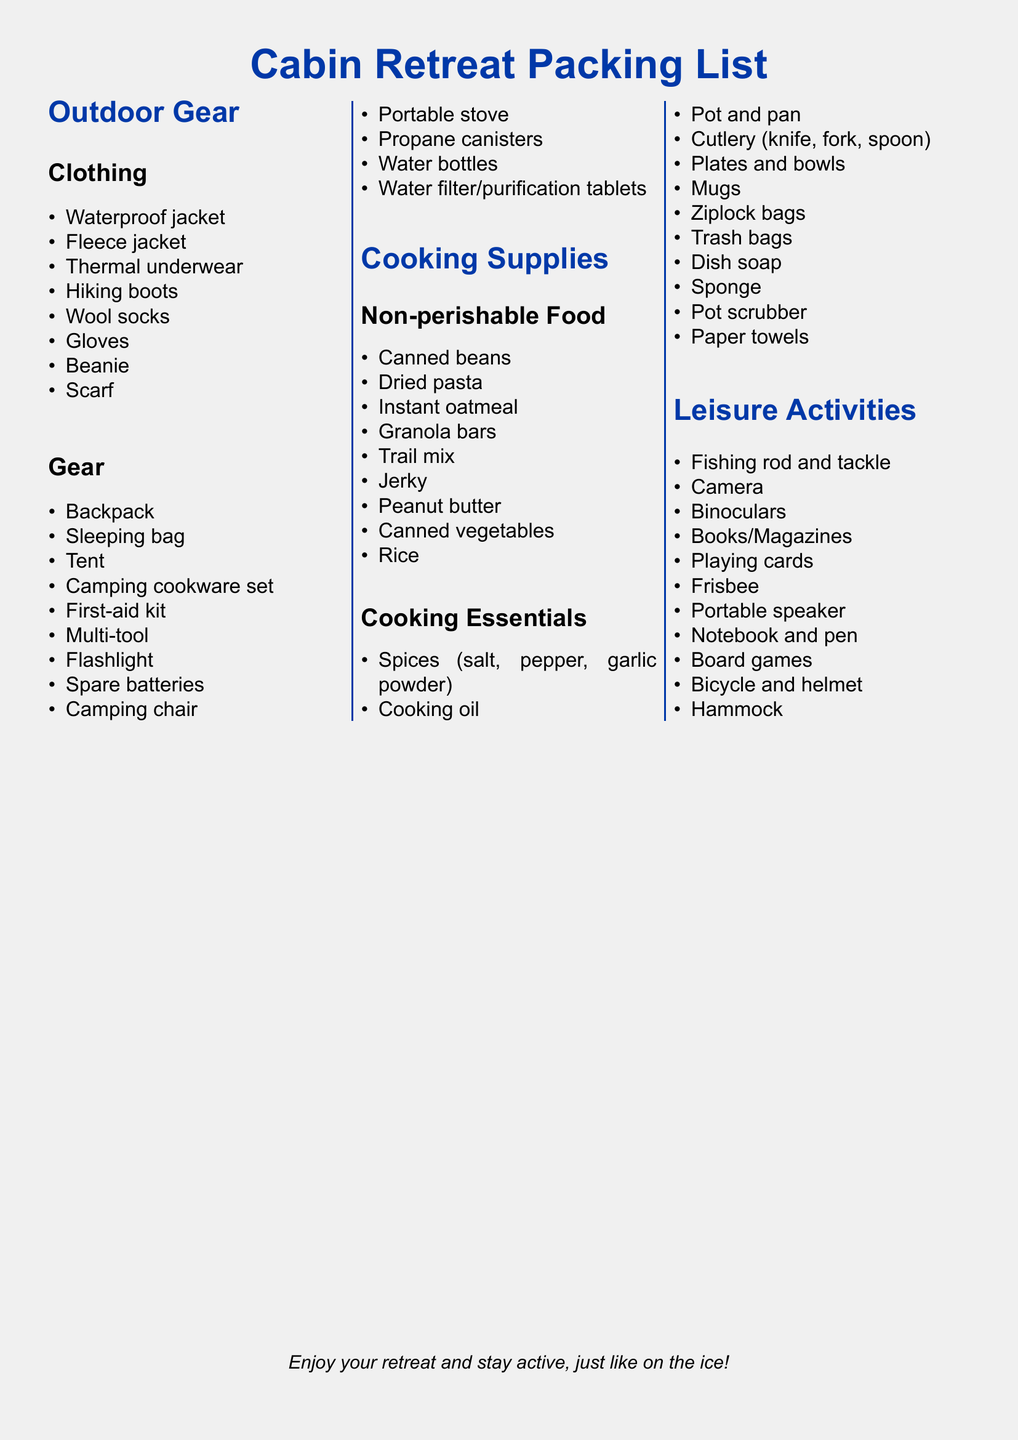What is the waterproof clothing item listed? The document lists "Waterproof jacket" under the clothing section of outdoor gear.
Answer: Waterproof jacket How many types of non-perishable food are mentioned? The document lists a total of 9 different types under non-perishable food.
Answer: 9 What essential cooking item is paired with the pot? The document specifically mentions "pan" alongside "pot" under cooking essentials.
Answer: Pan Which leisure activity involves tools for outdoor use? The document references "Fishing rod and tackle" as a leisure activity that involves tools.
Answer: Fishing rod and tackle What color theme is used for headings in the document? The headings in the document are colored in "hockeyblue" as specified in the color definition.
Answer: hockeyblue How many items are listed under outdoor gear gear? There are 12 items listed under the gear section of outdoor gear.
Answer: 12 Which item is mentioned for cleaning dishes? The document includes "Dish soap" under cooking essentials for cleaning dishes.
Answer: Dish soap What leisure activity can be enjoyed while resting? The document includes "Hammock," which is associated with relaxation.
Answer: Hammock What type of container is specified for trash? The document mentions "Trash bags" under cooking essentials for waste disposal.
Answer: Trash bags 